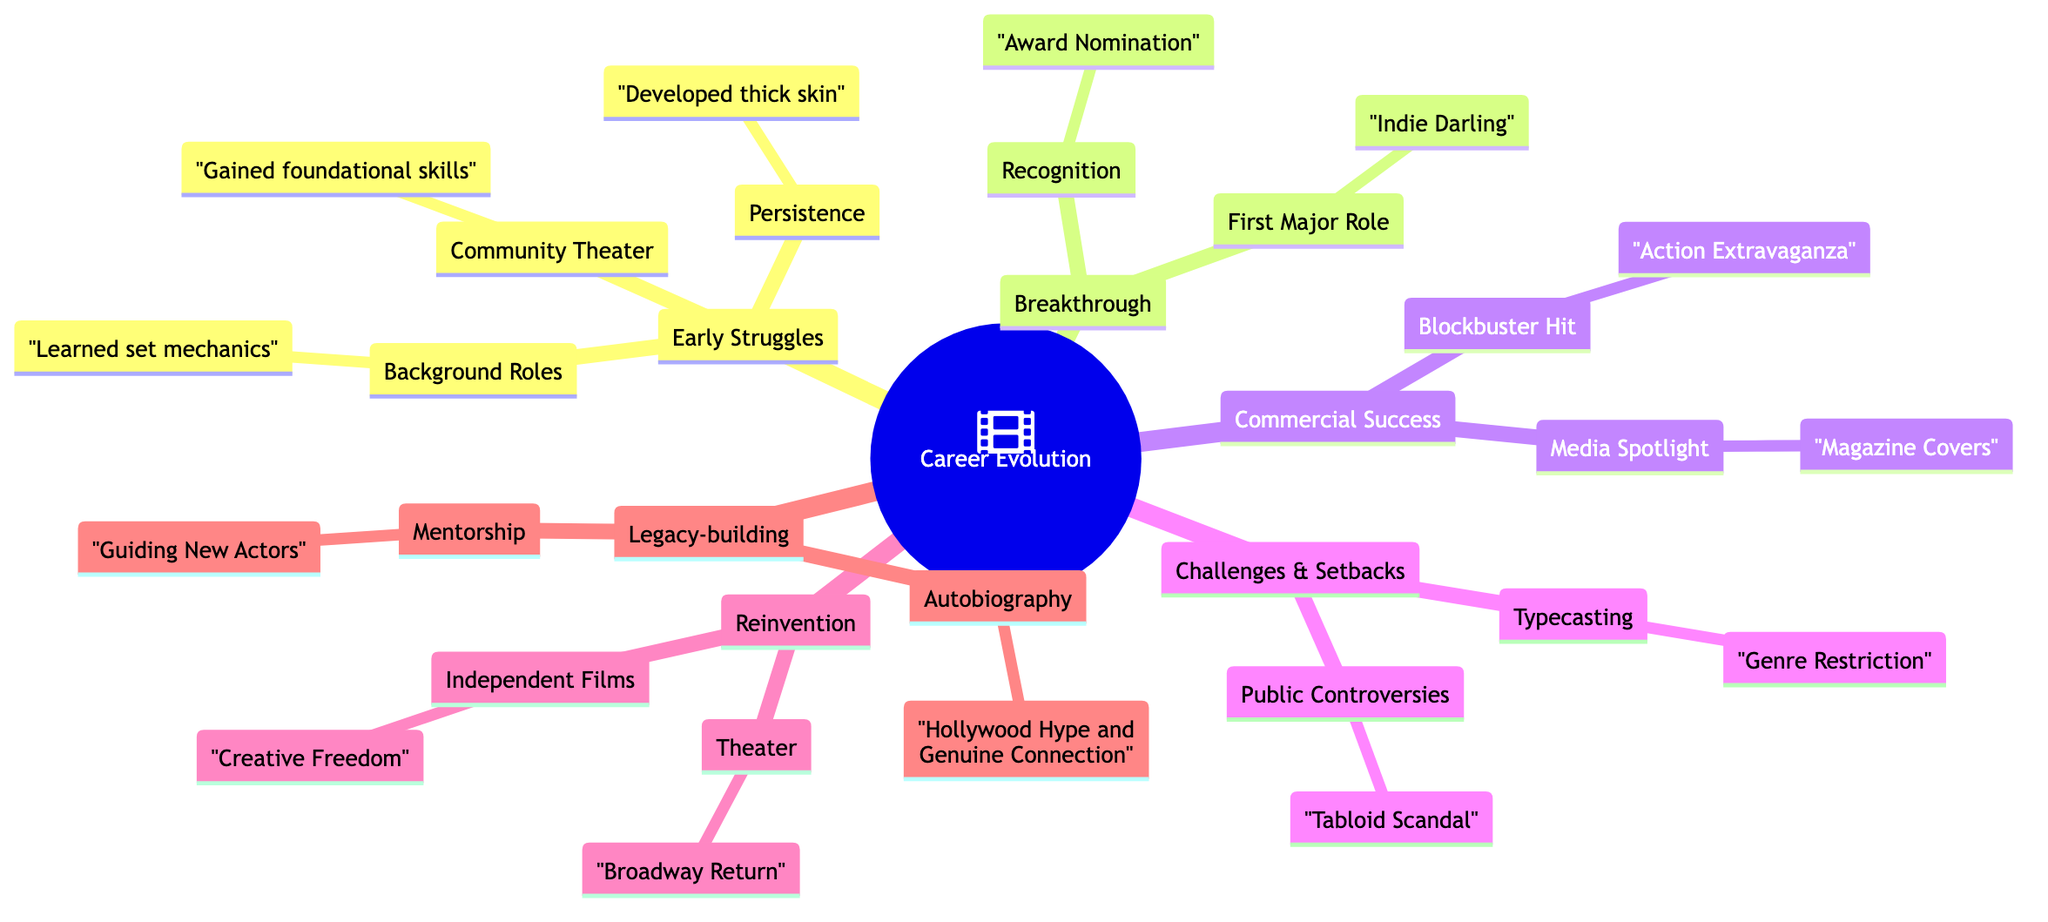What are the three main sections in the diagram? The diagram consists of five main sections: Early Struggles, Breakthrough, Commercial Success, Challenges & Setbacks, and Reinvention.
Answer: Early Struggles, Breakthrough, Commercial Success, Challenges & Setbacks, Reinvention How many lessons were learned under the category 'Challenges & Setbacks'? In the 'Challenges & Setbacks' section, there are two entries: Typecasting and Public Controversies, each with their own lessons learned.
Answer: 2 What film is associated with the First Major Role? The diagram indicates that the First Major Role is linked to the film 'Indie Darling.'
Answer: Indie Darling What was a key lesson learned in the 'Commercial Success' section? The 'Commercial Success' section highlights that a key lesson learned is about understanding the business side of entertainment.
Answer: Understanding the business side of entertainment Which milestone involves mentoring new actors? The diagram identifies Mentorship as the milestone involving the mentoring of new actors in the Legacy-building section.
Answer: Mentorship How does 'Reinvention' differ from 'Commercial Success'? 'Reinvention' focuses on returning to roots and pursuing creative freedom, while 'Commercial Success' centers around achieving fame and dealing with its pressures.
Answer: Focus on roots vs. fame pressures What is the significance of the 'Autobiography' in Legacy-building? The 'Autobiography' represents a reflection on career lessons and emphasizes the importance of authenticity, serving as a way to distill experiences into learning for others.
Answer: Reflection and authenticity Which section contains lessons about handling public controversies? The section titled 'Challenges & Setbacks' contains lessons related to navigating personal fallout from public controversies.
Answer: Challenges & Setbacks What recurring theme is highlighted in the lessons across the sections? A recurring theme throughout the lessons is the importance of authenticity and continuous personal growth throughout the career journey.
Answer: Authenticity and personal growth 